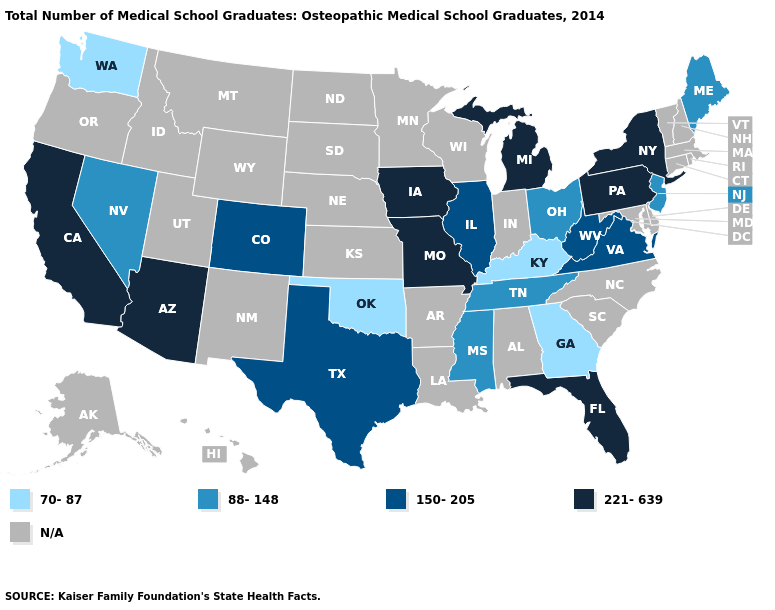Name the states that have a value in the range N/A?
Give a very brief answer. Alabama, Alaska, Arkansas, Connecticut, Delaware, Hawaii, Idaho, Indiana, Kansas, Louisiana, Maryland, Massachusetts, Minnesota, Montana, Nebraska, New Hampshire, New Mexico, North Carolina, North Dakota, Oregon, Rhode Island, South Carolina, South Dakota, Utah, Vermont, Wisconsin, Wyoming. Does Georgia have the lowest value in the USA?
Concise answer only. Yes. Among the states that border Alabama , which have the highest value?
Short answer required. Florida. Among the states that border Pennsylvania , does Ohio have the highest value?
Give a very brief answer. No. Which states have the highest value in the USA?
Quick response, please. Arizona, California, Florida, Iowa, Michigan, Missouri, New York, Pennsylvania. What is the value of Maine?
Write a very short answer. 88-148. Name the states that have a value in the range 150-205?
Be succinct. Colorado, Illinois, Texas, Virginia, West Virginia. Among the states that border Virginia , which have the highest value?
Answer briefly. West Virginia. What is the value of Oregon?
Write a very short answer. N/A. Among the states that border Alabama , does Georgia have the highest value?
Be succinct. No. What is the highest value in the West ?
Give a very brief answer. 221-639. Does Pennsylvania have the highest value in the USA?
Keep it brief. Yes. What is the lowest value in the USA?
Give a very brief answer. 70-87. Among the states that border Colorado , does Oklahoma have the highest value?
Give a very brief answer. No. Name the states that have a value in the range 70-87?
Keep it brief. Georgia, Kentucky, Oklahoma, Washington. 